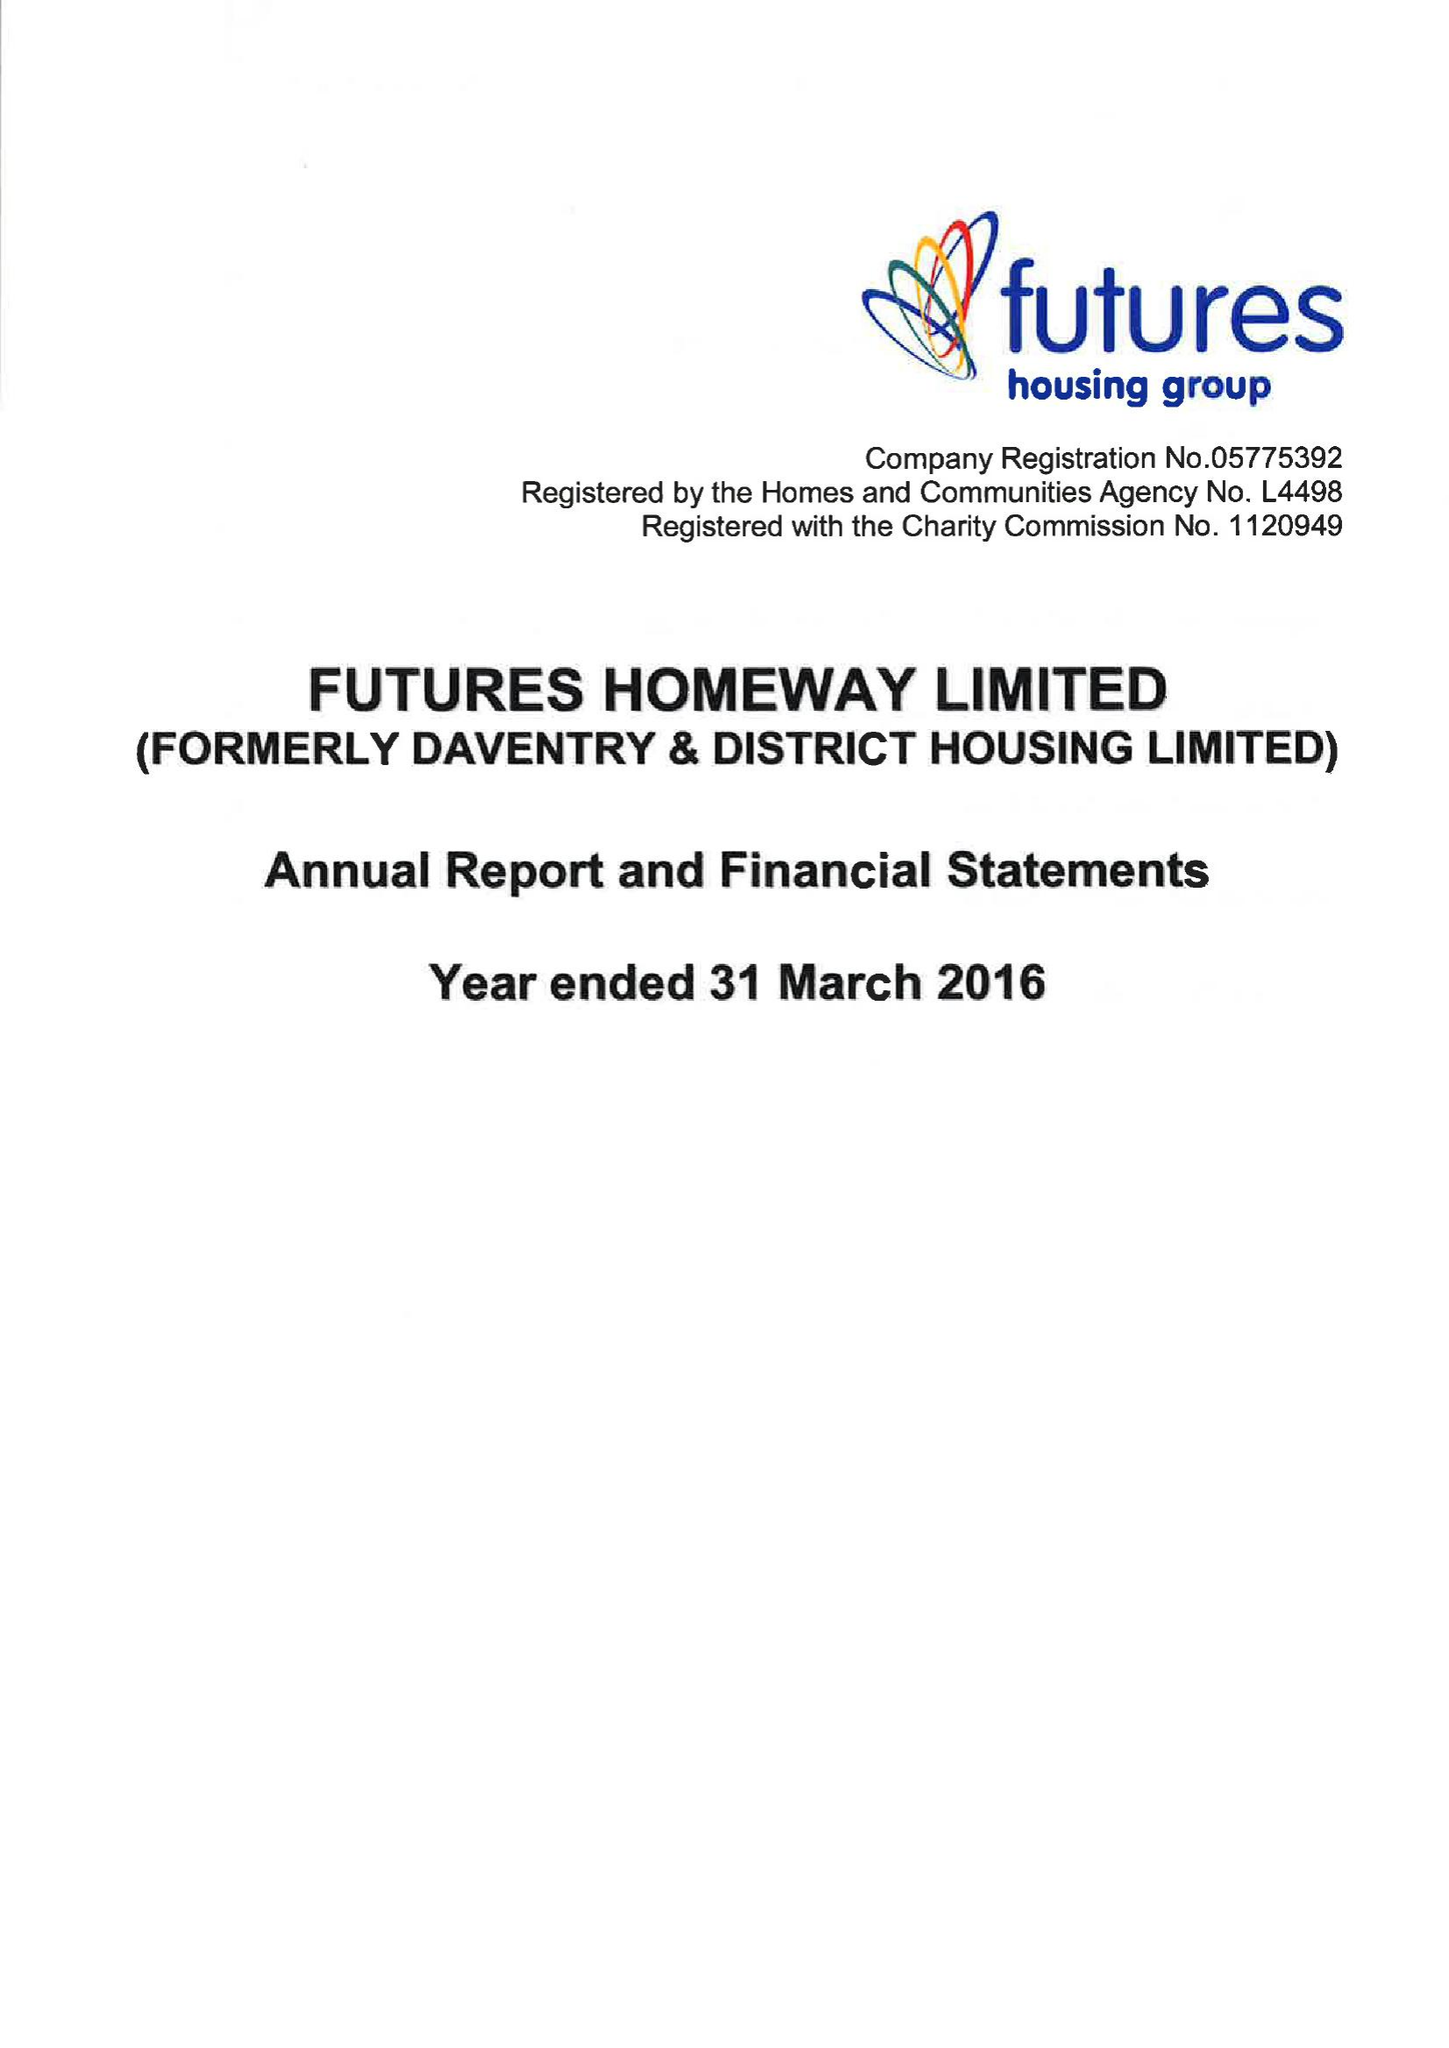What is the value for the report_date?
Answer the question using a single word or phrase. 2016-03-31 